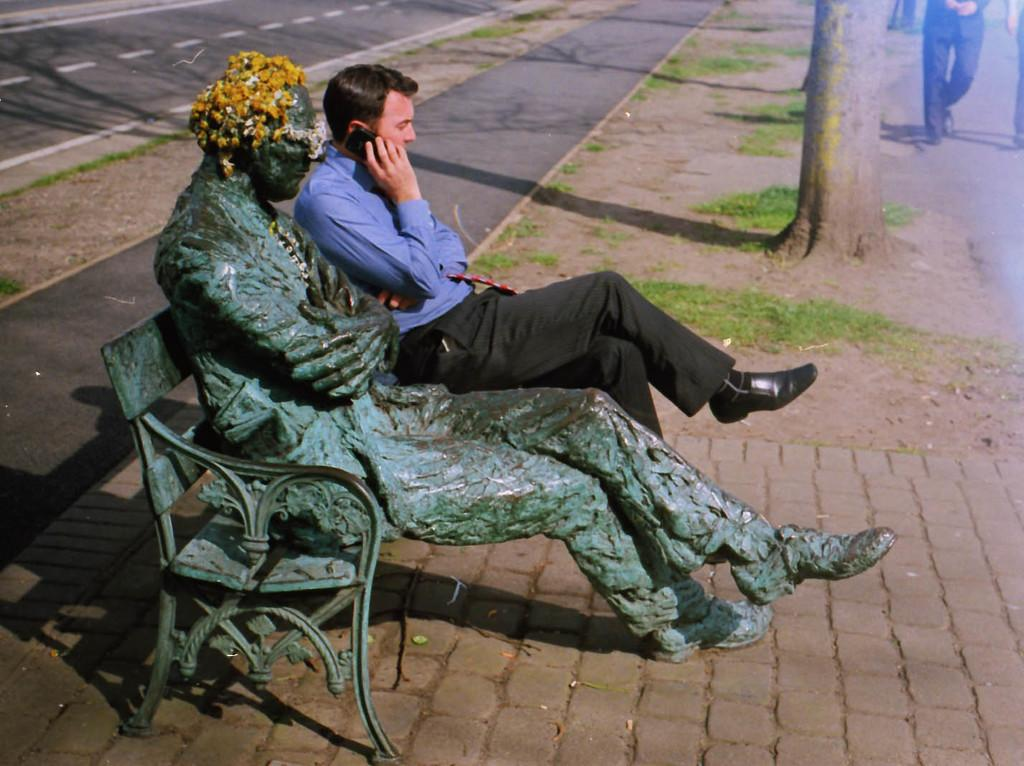What is the main subject on the iron bench in the image? There is a statue on an iron bench in the image. Who is sitting beside the statue? There is a man sitting beside the statue. What is the man wearing? The man is wearing a blue color shirt. What is the man doing while sitting beside the statue? The man is talking on the phone. What can be seen in the background of the image? There is a tree trunk and a road visible in the background. Can you see any eggnog being consumed by the man in the image? There is no eggnog present in the image. Is there a deer visible in the background of the image? There is no deer present in the image; only a tree trunk and a road are visible in the background. 